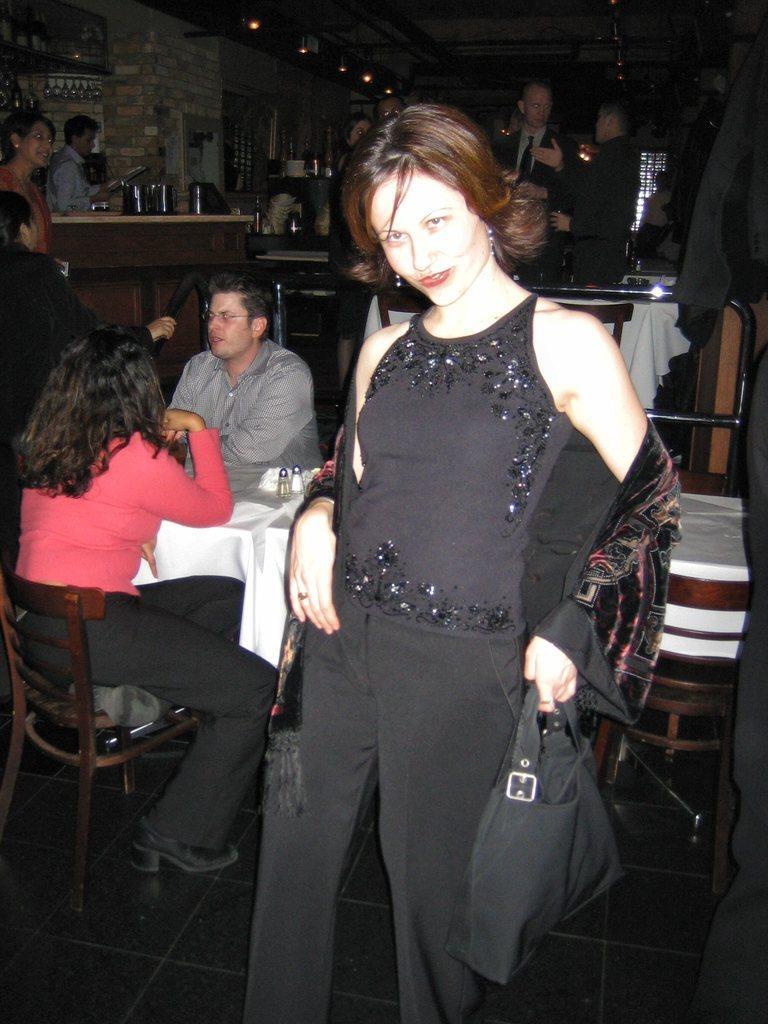Could you give a brief overview of what you see in this image? A lady wearing a black dress is holding a bag and standing. Behind her two persons are sitting on chairs. There are tables. In the background there are some persons standing. There are tables, bottles, lights and wall in the background. 